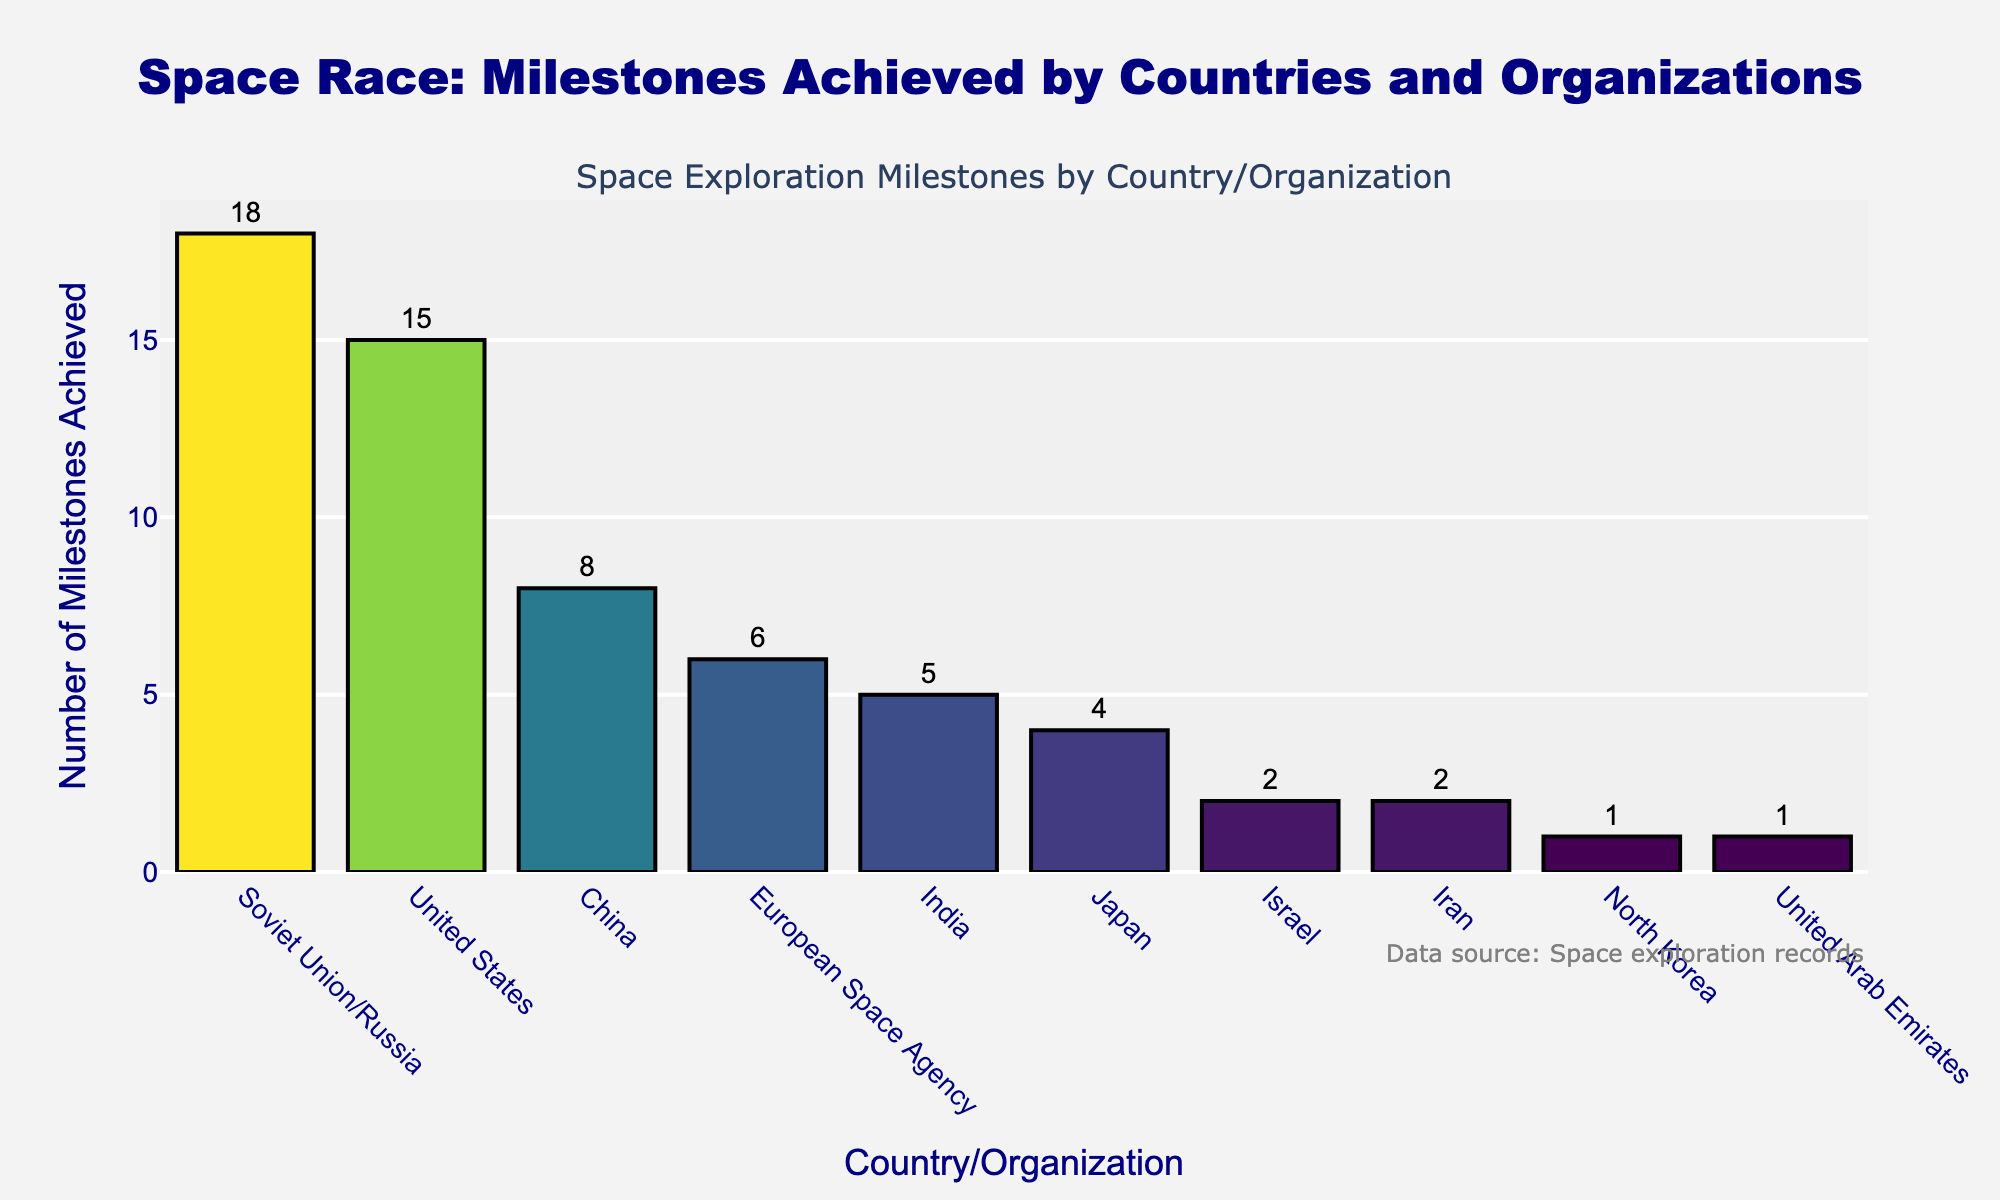Which country/organization achieved the most space exploration milestones? The tallest bar in the chart represents the country/organization with the most milestones. This bar corresponds to the Soviet Union/Russia.
Answer: Soviet Union/Russia Which two countries/organizations achieved the same number of space exploration milestones? By looking at the heights and labels of the bars, you can see that Israel and Iran both have bars of the same height, each representing 2 milestones.
Answer: Israel and Iran How many more milestones did the Soviet Union/Russia achieve than India? The bar for the Soviet Union/Russia is at 18 milestones while India is at 5 milestones. Subtracting India's milestones from Soviet Union/Russia’s gives 18 - 5 = 13.
Answer: 13 What is the median number of milestones achieved by the listed countries/organizations? List the milestones: 18, 15, 8, 6, 5, 4, 2, 2, 1, 1. The median is the middle value. Since there are 10 data points, the median is the average of the 5th and 6th values, (5 + 4) / 2 = 4.5.
Answer: 4.5 Which country/organization achieved fewer milestones than Japan but more than Israel? By looking at the bar heights and values, Japan achieved 4 milestones, and Israel achieved 2. India, with 5 milestones, is the only country in between.
Answer: India What percentage of the total milestones does the United States represent? Sum all the milestones: 18 + 15 + 8 + 6 + 5 + 4 + 2 + 2 + 1 + 1 = 62. The United States has 15 milestones. The percentage is (15 / 62) * 100 ≈ 24.2%.
Answer: 24.2% Which countries/organizations have achieved less than 5 milestones? Bars with heights below the 5-milestone mark include Japan (4), Israel (2), Iran (2), North Korea (1), and United Arab Emirates (1).
Answer: Japan, Israel, Iran, North Korea, United Arab Emirates How many milestones have been achieved by all countries/organizations combined? Add all the values: 18 + 15 + 8 + 6 + 5 + 4 + 2 + 2 + 1 + 1 = 62.
Answer: 62 Which country achieved twice as many milestones as Japan? Japan achieved 4 milestones. The country that achieved twice this amount is India with 5 milestones (4 * 2 = 8).
Answer: India 